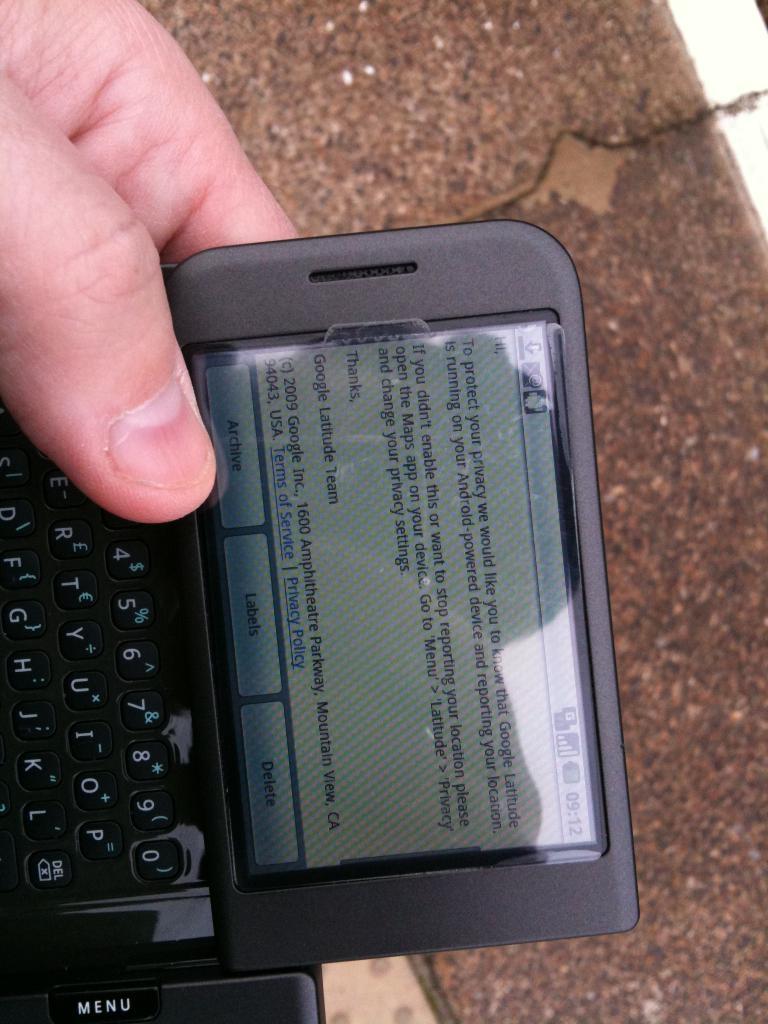What time is it on the phone?
Your answer should be compact. 9:12. 